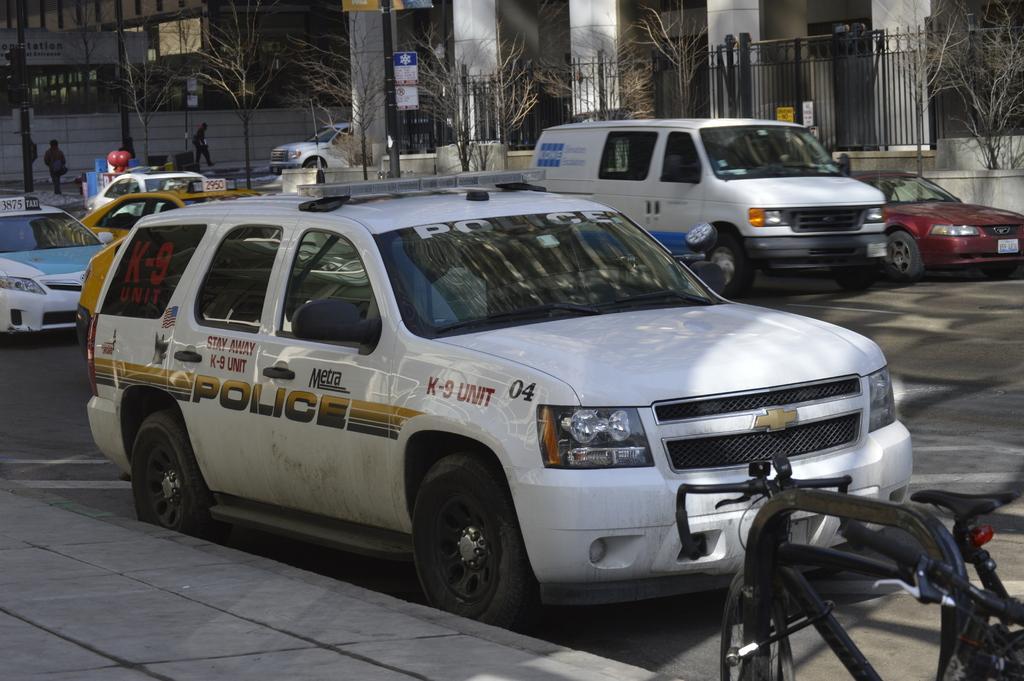Describe this image in one or two sentences. This image is taken outdoors. At the bottom of the image there is a sidewalk and a road. In the middle of the image a few cars are parked on the road. At the top of the image there is a building, a few trees, a railing, pillars and boards with text on them. Two men are walking on the road and there is a signal light. 